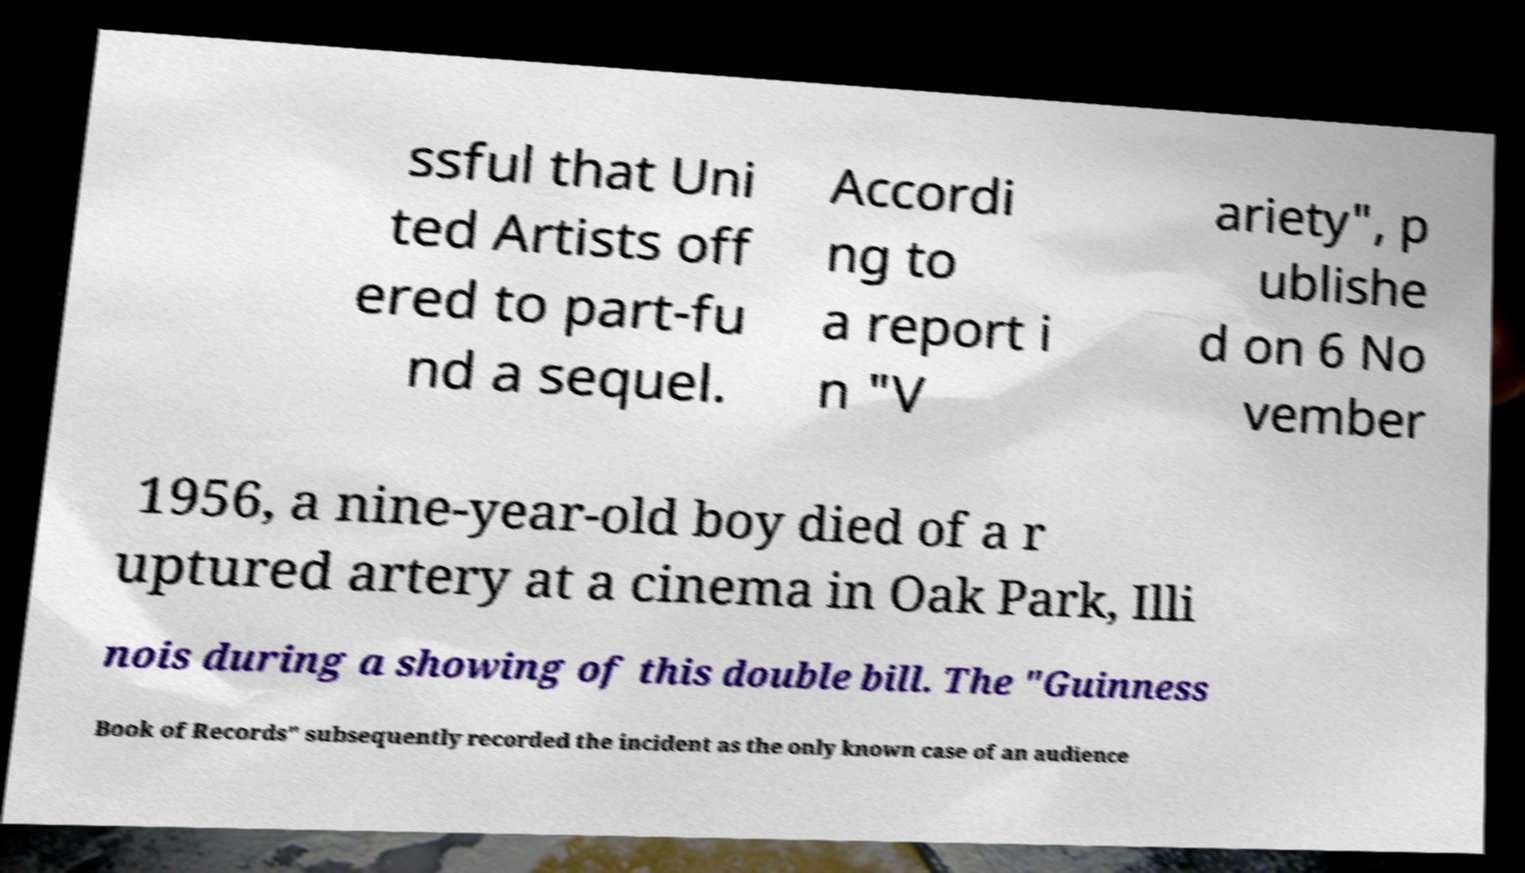Please read and relay the text visible in this image. What does it say? ssful that Uni ted Artists off ered to part-fu nd a sequel. Accordi ng to a report i n "V ariety", p ublishe d on 6 No vember 1956, a nine-year-old boy died of a r uptured artery at a cinema in Oak Park, Illi nois during a showing of this double bill. The "Guinness Book of Records" subsequently recorded the incident as the only known case of an audience 